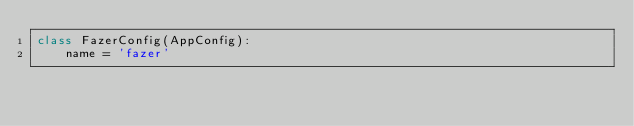Convert code to text. <code><loc_0><loc_0><loc_500><loc_500><_Python_>class FazerConfig(AppConfig):
    name = 'fazer'
</code> 